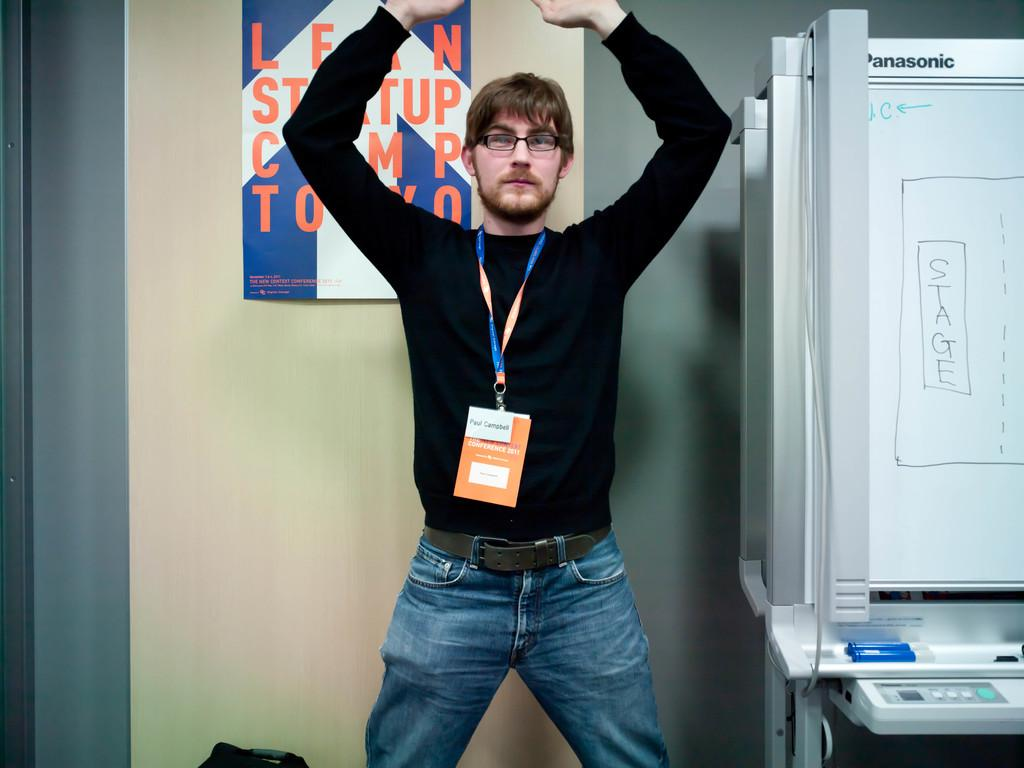<image>
Summarize the visual content of the image. A young man named Paul Campbell wears a tag with his name on it. 